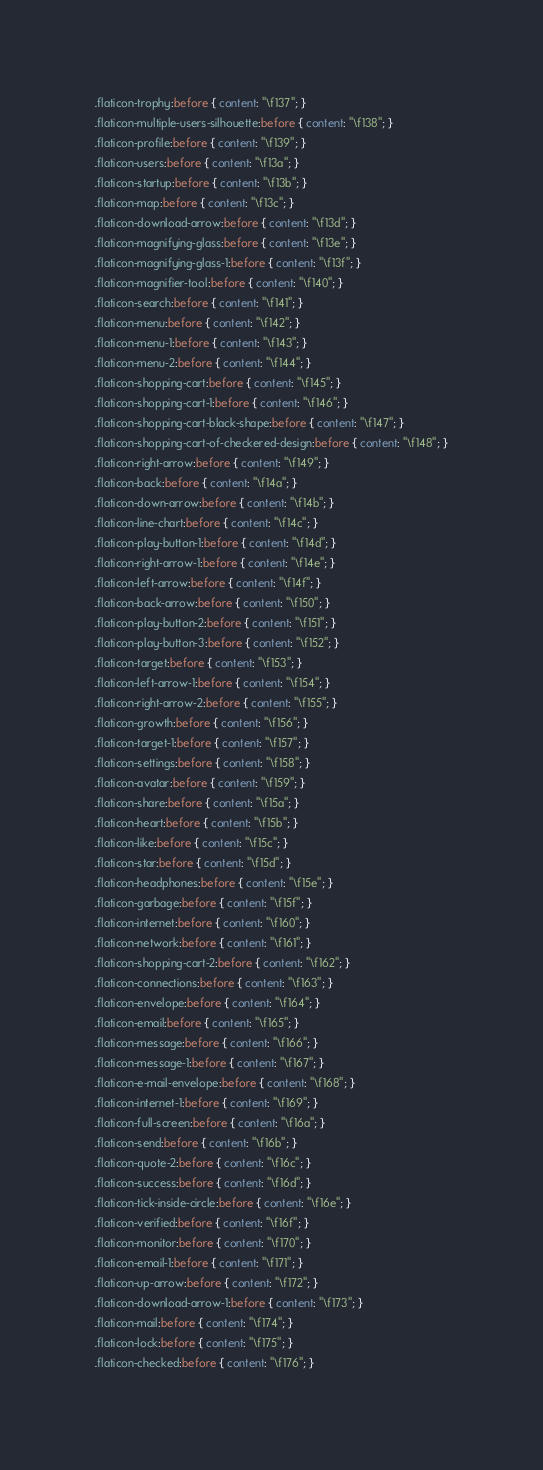Convert code to text. <code><loc_0><loc_0><loc_500><loc_500><_CSS_>.flaticon-trophy:before { content: "\f137"; }
.flaticon-multiple-users-silhouette:before { content: "\f138"; }
.flaticon-profile:before { content: "\f139"; }
.flaticon-users:before { content: "\f13a"; }
.flaticon-startup:before { content: "\f13b"; }
.flaticon-map:before { content: "\f13c"; }
.flaticon-download-arrow:before { content: "\f13d"; }
.flaticon-magnifying-glass:before { content: "\f13e"; }
.flaticon-magnifying-glass-1:before { content: "\f13f"; }
.flaticon-magnifier-tool:before { content: "\f140"; }
.flaticon-search:before { content: "\f141"; }
.flaticon-menu:before { content: "\f142"; }
.flaticon-menu-1:before { content: "\f143"; }
.flaticon-menu-2:before { content: "\f144"; }
.flaticon-shopping-cart:before { content: "\f145"; }
.flaticon-shopping-cart-1:before { content: "\f146"; }
.flaticon-shopping-cart-black-shape:before { content: "\f147"; }
.flaticon-shopping-cart-of-checkered-design:before { content: "\f148"; }
.flaticon-right-arrow:before { content: "\f149"; }
.flaticon-back:before { content: "\f14a"; }
.flaticon-down-arrow:before { content: "\f14b"; }
.flaticon-line-chart:before { content: "\f14c"; }
.flaticon-play-button-1:before { content: "\f14d"; }
.flaticon-right-arrow-1:before { content: "\f14e"; }
.flaticon-left-arrow:before { content: "\f14f"; }
.flaticon-back-arrow:before { content: "\f150"; }
.flaticon-play-button-2:before { content: "\f151"; }
.flaticon-play-button-3:before { content: "\f152"; }
.flaticon-target:before { content: "\f153"; }
.flaticon-left-arrow-1:before { content: "\f154"; }
.flaticon-right-arrow-2:before { content: "\f155"; }
.flaticon-growth:before { content: "\f156"; }
.flaticon-target-1:before { content: "\f157"; }
.flaticon-settings:before { content: "\f158"; }
.flaticon-avatar:before { content: "\f159"; }
.flaticon-share:before { content: "\f15a"; }
.flaticon-heart:before { content: "\f15b"; }
.flaticon-like:before { content: "\f15c"; }
.flaticon-star:before { content: "\f15d"; }
.flaticon-headphones:before { content: "\f15e"; }
.flaticon-garbage:before { content: "\f15f"; }
.flaticon-internet:before { content: "\f160"; }
.flaticon-network:before { content: "\f161"; }
.flaticon-shopping-cart-2:before { content: "\f162"; }
.flaticon-connections:before { content: "\f163"; }
.flaticon-envelope:before { content: "\f164"; }
.flaticon-email:before { content: "\f165"; }
.flaticon-message:before { content: "\f166"; }
.flaticon-message-1:before { content: "\f167"; }
.flaticon-e-mail-envelope:before { content: "\f168"; }
.flaticon-internet-1:before { content: "\f169"; }
.flaticon-full-screen:before { content: "\f16a"; }
.flaticon-send:before { content: "\f16b"; }
.flaticon-quote-2:before { content: "\f16c"; }
.flaticon-success:before { content: "\f16d"; }
.flaticon-tick-inside-circle:before { content: "\f16e"; }
.flaticon-verified:before { content: "\f16f"; }
.flaticon-monitor:before { content: "\f170"; }
.flaticon-email-1:before { content: "\f171"; }
.flaticon-up-arrow:before { content: "\f172"; }
.flaticon-download-arrow-1:before { content: "\f173"; }
.flaticon-mail:before { content: "\f174"; }
.flaticon-lock:before { content: "\f175"; }
.flaticon-checked:before { content: "\f176"; }</code> 